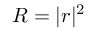<formula> <loc_0><loc_0><loc_500><loc_500>R = | r | ^ { 2 }</formula> 